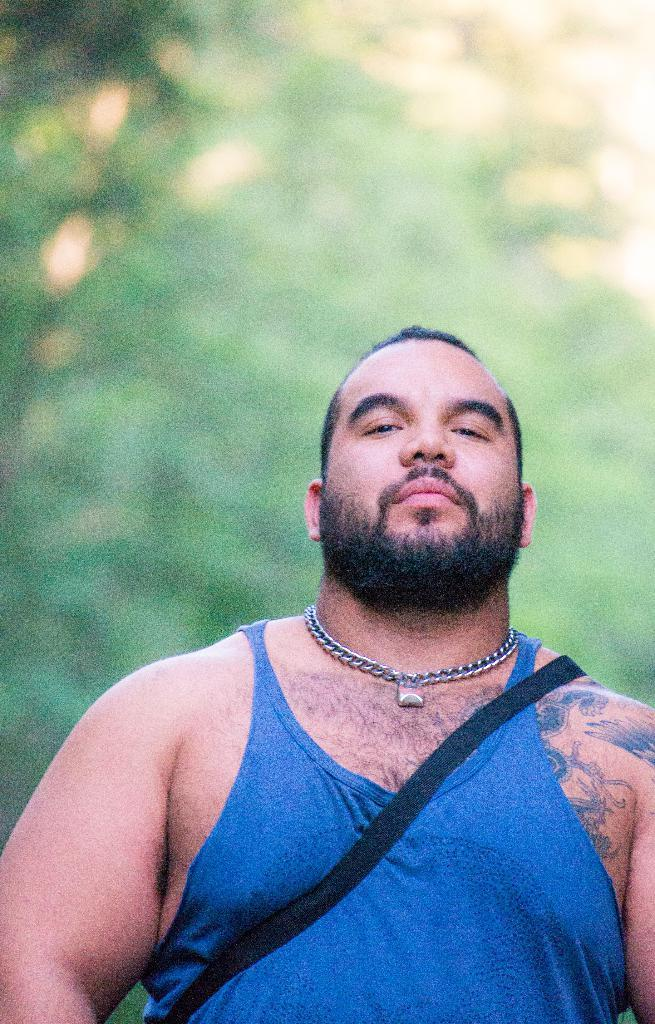Who is present in the image? There is a person in the image. What are they wearing? The person is wearing a blue baniyan. Are there any accessories visible on the person? Yes, the person has a chain on their body. What additional features can be seen on the person's body? The person has tattoos on their body. What type of mask is the person wearing in the image? There is no mask visible on the person in the image. 